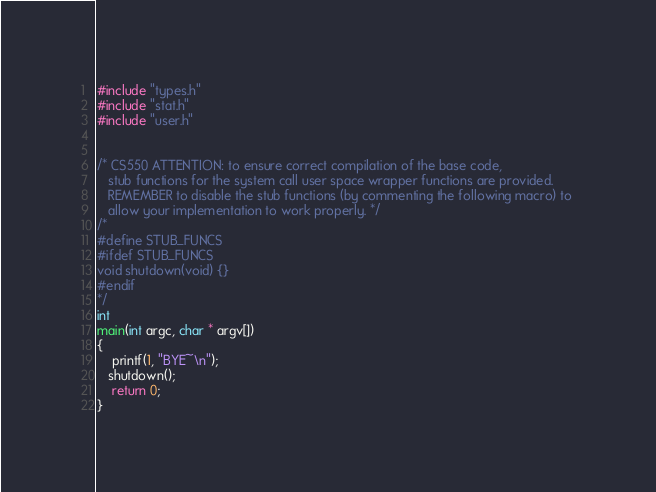<code> <loc_0><loc_0><loc_500><loc_500><_C_>#include "types.h"
#include "stat.h"
#include "user.h"


/* CS550 ATTENTION: to ensure correct compilation of the base code, 
   stub functions for the system call user space wrapper functions are provided. 
   REMEMBER to disable the stub functions (by commenting the following macro) to 
   allow your implementation to work properly. */
/*
#define STUB_FUNCS
#ifdef STUB_FUNCS
void shutdown(void) {}
#endif
*/
int 
main(int argc, char * argv[])
{
    printf(1, "BYE~\n");
   shutdown();
    return 0;
}
</code> 